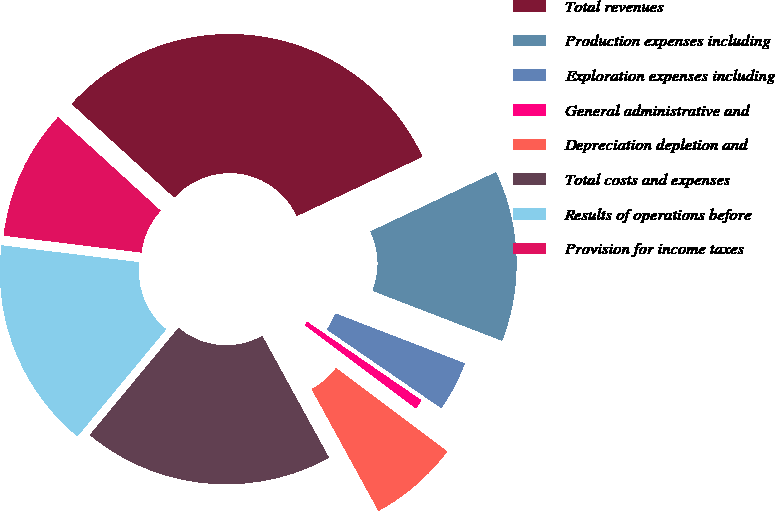<chart> <loc_0><loc_0><loc_500><loc_500><pie_chart><fcel>Total revenues<fcel>Production expenses including<fcel>Exploration expenses including<fcel>General administrative and<fcel>Depreciation depletion and<fcel>Total costs and expenses<fcel>Results of operations before<fcel>Provision for income taxes<nl><fcel>31.21%<fcel>12.88%<fcel>3.72%<fcel>0.67%<fcel>6.77%<fcel>18.99%<fcel>15.94%<fcel>9.83%<nl></chart> 